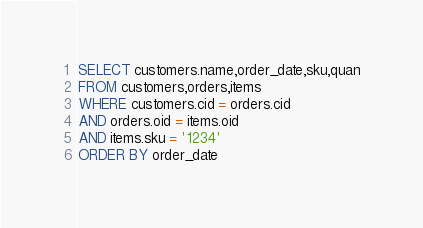Convert code to text. <code><loc_0><loc_0><loc_500><loc_500><_SQL_>SELECT customers.name,order_date,sku,quan
FROM customers,orders,items
WHERE customers.cid = orders.cid
AND orders.oid = items.oid
AND items.sku = '1234'
ORDER BY order_date</code> 